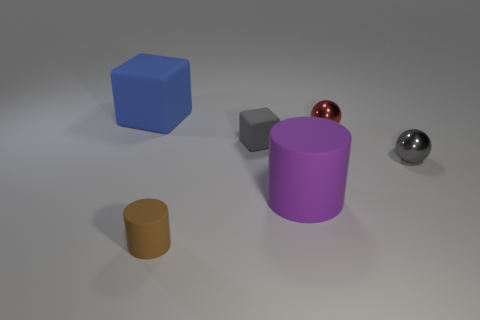There is a metal ball that is the same color as the tiny matte cube; what is its size?
Offer a very short reply. Small. What is the shape of the thing that is the same color as the small rubber block?
Your answer should be compact. Sphere. Is the shape of the large matte object that is in front of the blue thing the same as  the tiny red object?
Give a very brief answer. No. What color is the other object that is the same shape as the small gray metal thing?
Make the answer very short. Red. Are there the same number of tiny gray balls behind the large cube and tiny gray metal things?
Offer a terse response. No. What number of objects are on the right side of the tiny gray rubber thing and in front of the tiny gray metal object?
Your answer should be compact. 1. What is the size of the gray matte object that is the same shape as the blue thing?
Make the answer very short. Small. What number of other big objects are made of the same material as the purple object?
Your response must be concise. 1. Is the number of gray balls that are in front of the big rubber cylinder less than the number of tiny matte cylinders?
Make the answer very short. Yes. What number of tiny gray rubber balls are there?
Keep it short and to the point. 0. 